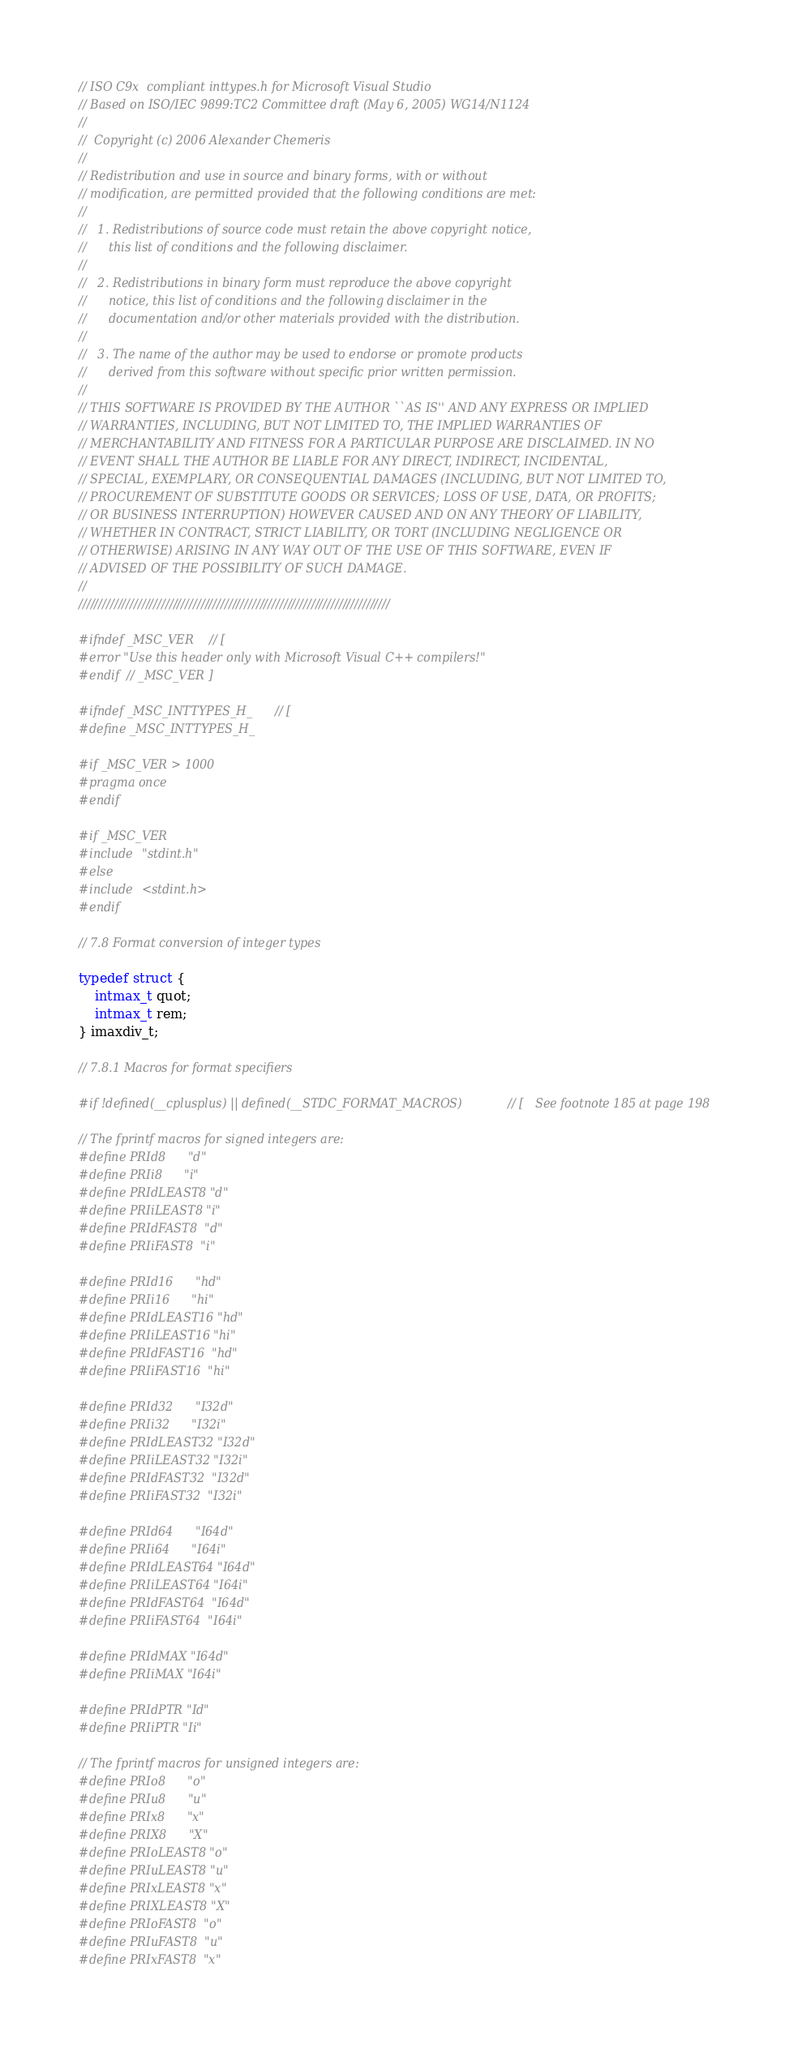<code> <loc_0><loc_0><loc_500><loc_500><_C_>// ISO C9x  compliant inttypes.h for Microsoft Visual Studio
// Based on ISO/IEC 9899:TC2 Committee draft (May 6, 2005) WG14/N1124 
// 
//  Copyright (c) 2006 Alexander Chemeris
// 
// Redistribution and use in source and binary forms, with or without
// modification, are permitted provided that the following conditions are met:
// 
//   1. Redistributions of source code must retain the above copyright notice,
//      this list of conditions and the following disclaimer.
// 
//   2. Redistributions in binary form must reproduce the above copyright
//      notice, this list of conditions and the following disclaimer in the
//      documentation and/or other materials provided with the distribution.
// 
//   3. The name of the author may be used to endorse or promote products
//      derived from this software without specific prior written permission.
// 
// THIS SOFTWARE IS PROVIDED BY THE AUTHOR ``AS IS'' AND ANY EXPRESS OR IMPLIED
// WARRANTIES, INCLUDING, BUT NOT LIMITED TO, THE IMPLIED WARRANTIES OF
// MERCHANTABILITY AND FITNESS FOR A PARTICULAR PURPOSE ARE DISCLAIMED. IN NO
// EVENT SHALL THE AUTHOR BE LIABLE FOR ANY DIRECT, INDIRECT, INCIDENTAL,
// SPECIAL, EXEMPLARY, OR CONSEQUENTIAL DAMAGES (INCLUDING, BUT NOT LIMITED TO,
// PROCUREMENT OF SUBSTITUTE GOODS OR SERVICES; LOSS OF USE, DATA, OR PROFITS;
// OR BUSINESS INTERRUPTION) HOWEVER CAUSED AND ON ANY THEORY OF LIABILITY, 
// WHETHER IN CONTRACT, STRICT LIABILITY, OR TORT (INCLUDING NEGLIGENCE OR
// OTHERWISE) ARISING IN ANY WAY OUT OF THE USE OF THIS SOFTWARE, EVEN IF
// ADVISED OF THE POSSIBILITY OF SUCH DAMAGE.
// 
///////////////////////////////////////////////////////////////////////////////

#ifndef _MSC_VER // [
#error "Use this header only with Microsoft Visual C++ compilers!"
#endif // _MSC_VER ]

#ifndef _MSC_INTTYPES_H_ // [
#define _MSC_INTTYPES_H_

#if _MSC_VER > 1000
#pragma once
#endif

#if _MSC_VER
#include "stdint.h"
#else
#include <stdint.h>
#endif

// 7.8 Format conversion of integer types

typedef struct {
    intmax_t quot;
    intmax_t rem;
} imaxdiv_t;

// 7.8.1 Macros for format specifiers

#if !defined(__cplusplus) || defined(__STDC_FORMAT_MACROS) // [   See footnote 185 at page 198

// The fprintf macros for signed integers are:
#define PRId8      "d"
#define PRIi8      "i"
#define PRIdLEAST8 "d"
#define PRIiLEAST8 "i"
#define PRIdFAST8  "d"
#define PRIiFAST8  "i"

#define PRId16      "hd"
#define PRIi16      "hi"
#define PRIdLEAST16 "hd"
#define PRIiLEAST16 "hi"
#define PRIdFAST16  "hd"
#define PRIiFAST16  "hi"

#define PRId32      "I32d"
#define PRIi32      "I32i"
#define PRIdLEAST32 "I32d"
#define PRIiLEAST32 "I32i"
#define PRIdFAST32  "I32d"
#define PRIiFAST32  "I32i"

#define PRId64      "I64d"
#define PRIi64      "I64i"
#define PRIdLEAST64 "I64d"
#define PRIiLEAST64 "I64i"
#define PRIdFAST64  "I64d"
#define PRIiFAST64  "I64i"

#define PRIdMAX "I64d"
#define PRIiMAX "I64i"

#define PRIdPTR "Id"
#define PRIiPTR "Ii"

// The fprintf macros for unsigned integers are:
#define PRIo8      "o"
#define PRIu8      "u"
#define PRIx8      "x"
#define PRIX8      "X"
#define PRIoLEAST8 "o"
#define PRIuLEAST8 "u"
#define PRIxLEAST8 "x"
#define PRIXLEAST8 "X"
#define PRIoFAST8  "o"
#define PRIuFAST8  "u"
#define PRIxFAST8  "x"</code> 